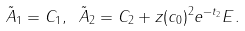<formula> <loc_0><loc_0><loc_500><loc_500>\tilde { A } _ { 1 } = C _ { 1 } , \ \tilde { A } _ { 2 } = C _ { 2 } + z ( c _ { 0 } ) ^ { 2 } e ^ { - t _ { 2 } } E .</formula> 